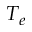<formula> <loc_0><loc_0><loc_500><loc_500>T _ { e }</formula> 